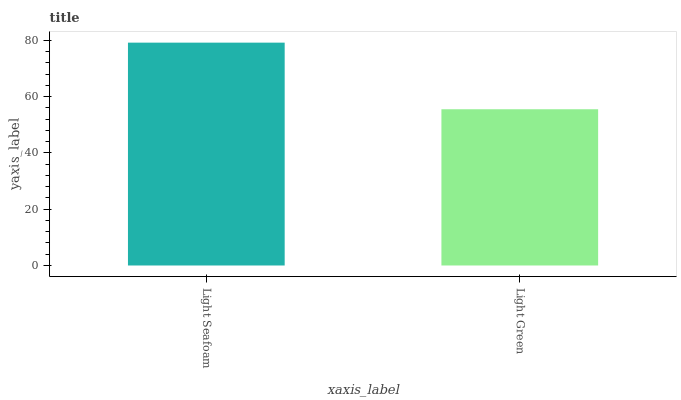Is Light Green the minimum?
Answer yes or no. Yes. Is Light Seafoam the maximum?
Answer yes or no. Yes. Is Light Green the maximum?
Answer yes or no. No. Is Light Seafoam greater than Light Green?
Answer yes or no. Yes. Is Light Green less than Light Seafoam?
Answer yes or no. Yes. Is Light Green greater than Light Seafoam?
Answer yes or no. No. Is Light Seafoam less than Light Green?
Answer yes or no. No. Is Light Seafoam the high median?
Answer yes or no. Yes. Is Light Green the low median?
Answer yes or no. Yes. Is Light Green the high median?
Answer yes or no. No. Is Light Seafoam the low median?
Answer yes or no. No. 